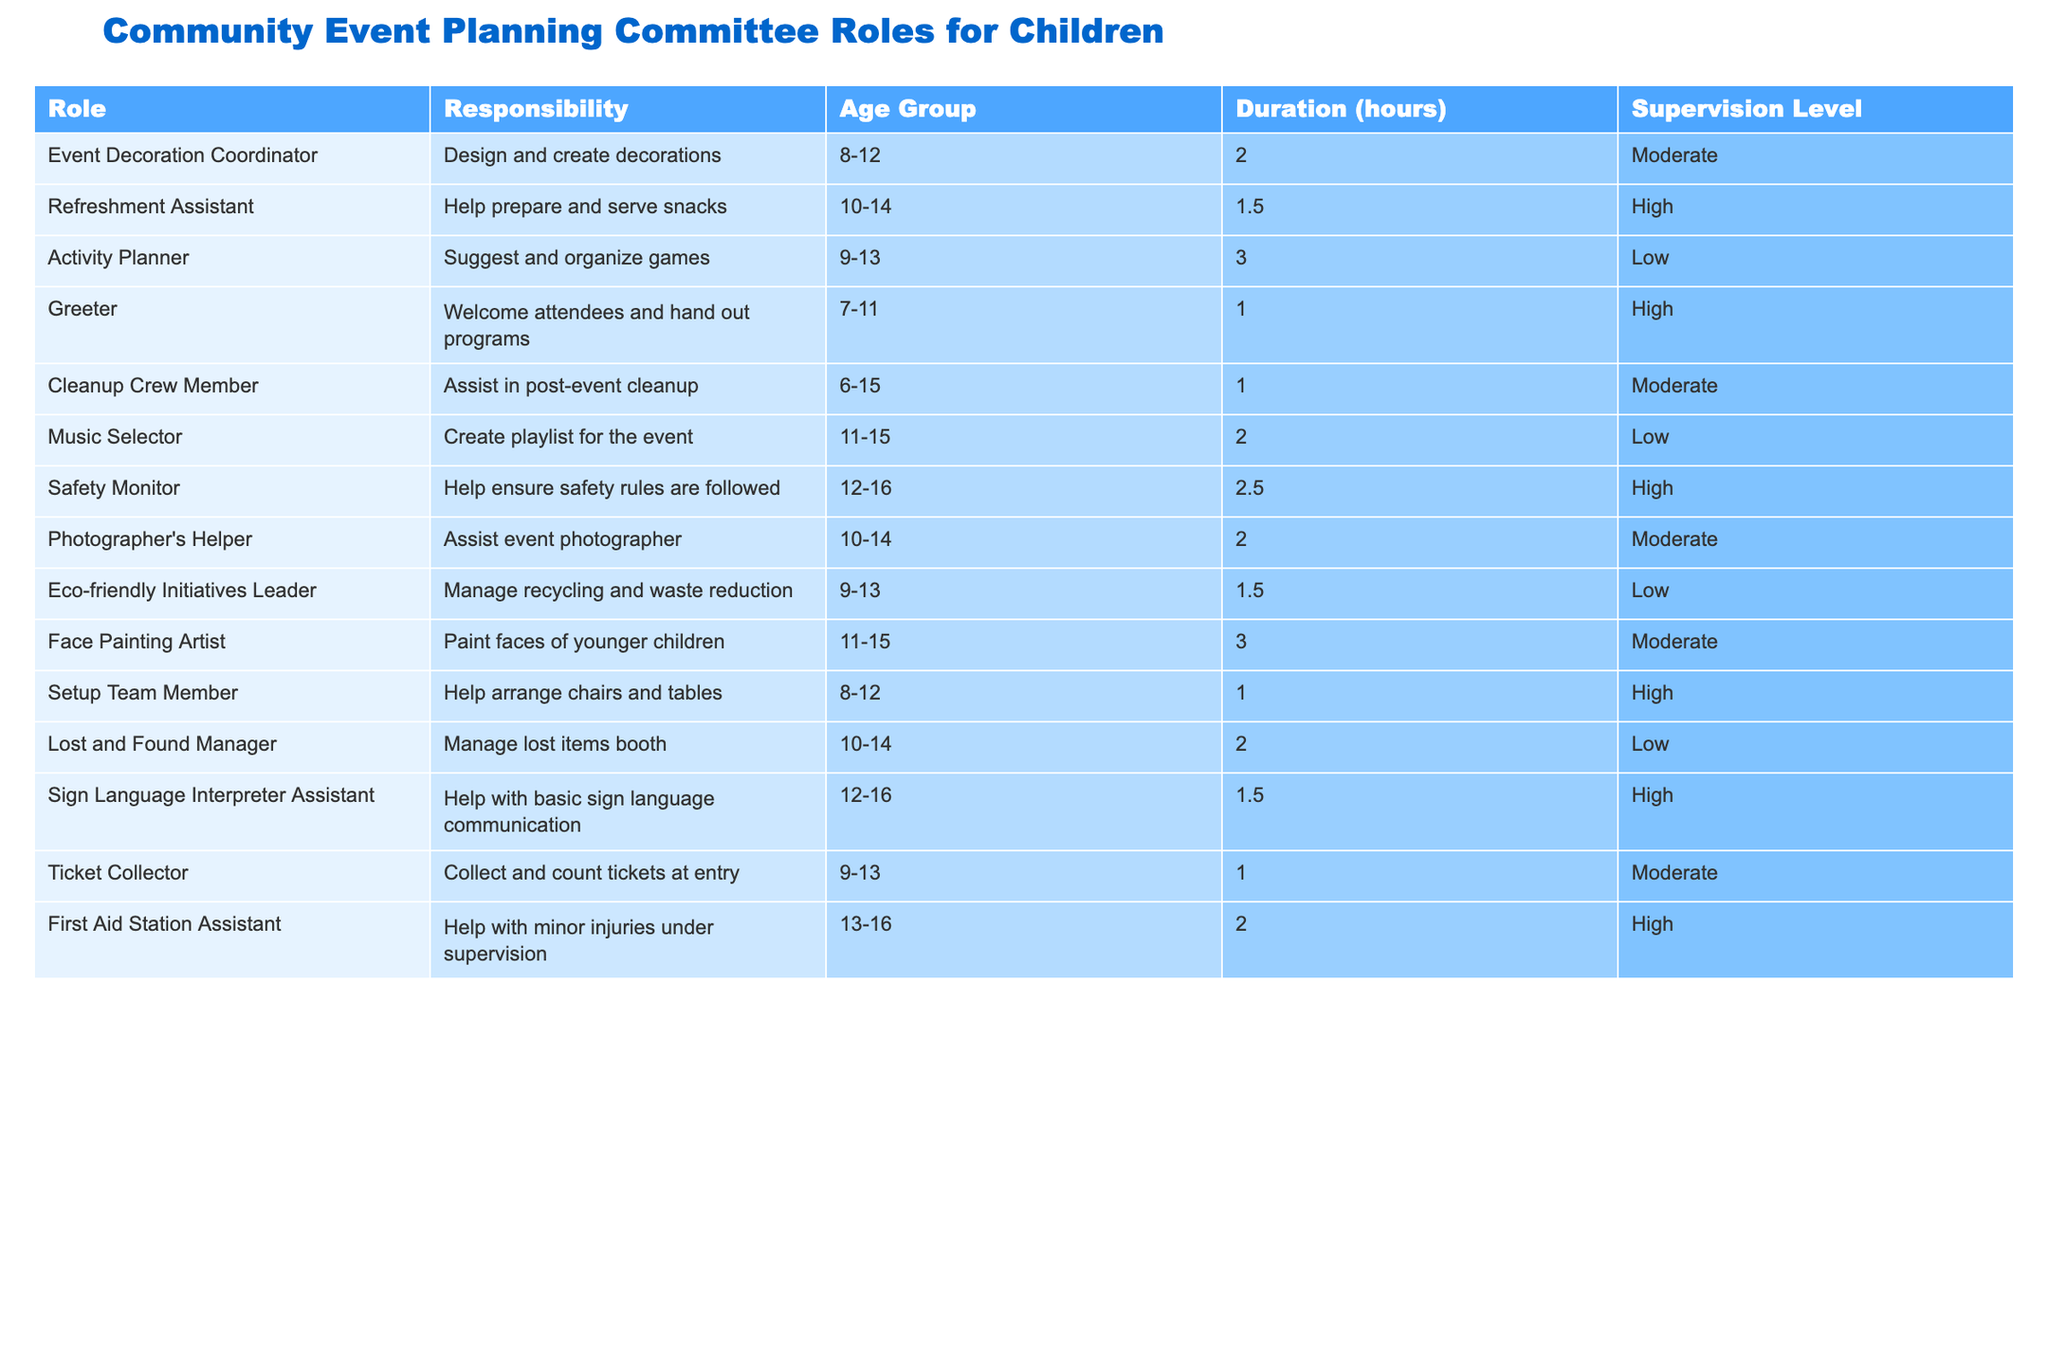What is the responsibility of the Event Decoration Coordinator? The Event Decoration Coordinator is responsible for designing and creating decorations for the event, as stated in the "Responsibility" column.
Answer: Design and create decorations How many hours does the Activity Planner work? The Activity Planner works for a total of 3 hours, as indicated in the "Duration" column for this role.
Answer: 3 hours Are any roles specifically designated for children aged 6-8? Yes, the "Greeter" and "Cleanup Crew Member" roles are designed for children aged 6-15 and ages start from 6, making them suitable for children aged 6-8.
Answer: Yes What is the longest duration role and how many hours does it involve? The "Activity Planner" and "Face Painting Artist" both have the longest duration of 3 hours listed in the table.
Answer: 3 hours What percentage of roles require high supervision? There are 6 roles that require high supervision out of a total of 13 roles, so the percentage is (6/13) * 100 = approximately 46.15%.
Answer: 46.15% Which role has the age group of 12-16 and requires high supervision? The roles of "Safety Monitor" and "First Aid Station Assistant" fit this criteria, as both have the age group of 12-16 and require high supervision.
Answer: Safety Monitor and First Aid Station Assistant How does the supervision level affect the responsibilities assigned to children? Roles requiring high supervision typically involve more sensitive or safety-related responsibilities, such as handling snacks, ensuring safety rules, or assisting with first aid, which necessitates closer adult oversight.
Answer: High supervision for sensitive tasks Which two roles have the same duration of 2 hours? The "Music Selector" and "Lost and Found Manager" both have a duration of 2 hours, as shown in the "Duration" column of the table.
Answer: Music Selector and Lost and Found Manager Is there a role for ages 6-7? Yes, the "Greeter" role is open for children aged 7-11, thereby including ages 6-7 indirectly since it starts at age 7.
Answer: Yes What are the two lowest supervision roles listed in the table? The "Activity Planner" and "Music Selector" are the two roles with a low supervision level listed in the "Supervision Level" column.
Answer: Activity Planner and Music Selector 